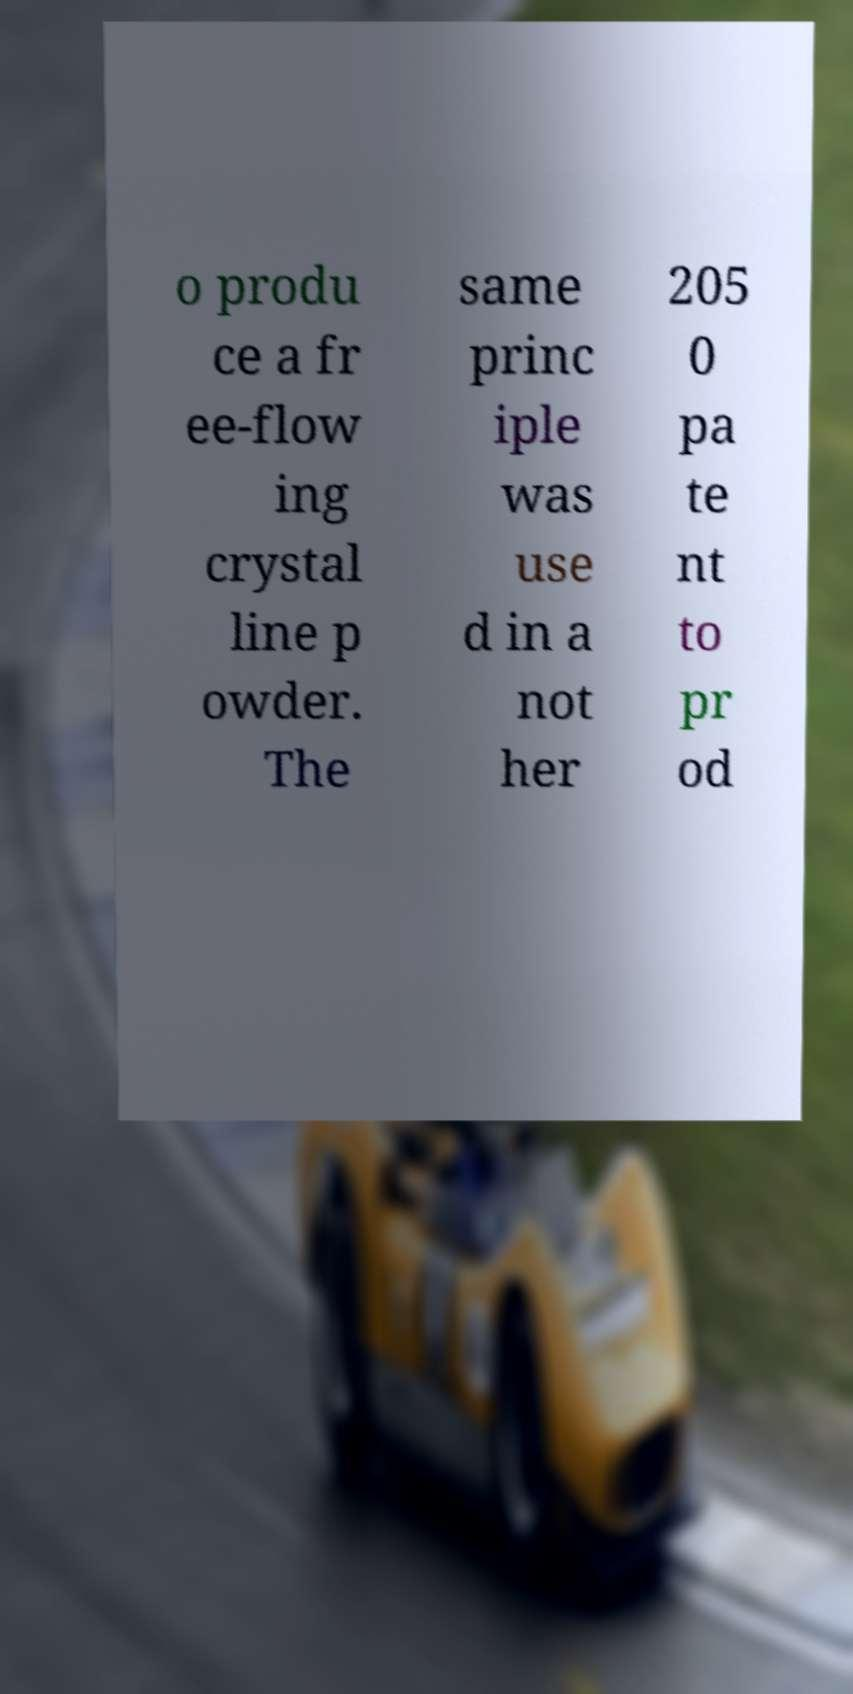There's text embedded in this image that I need extracted. Can you transcribe it verbatim? o produ ce a fr ee-flow ing crystal line p owder. The same princ iple was use d in a not her 205 0 pa te nt to pr od 